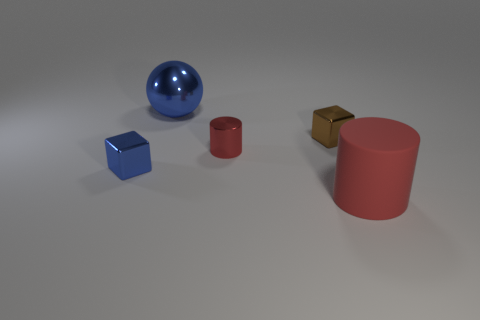How many cylinders are made of the same material as the sphere? None of the cylinders are made of the same material as the sphere. The sphere appears to have a shiny, reflective surface while both cylinders have a matte finish. 